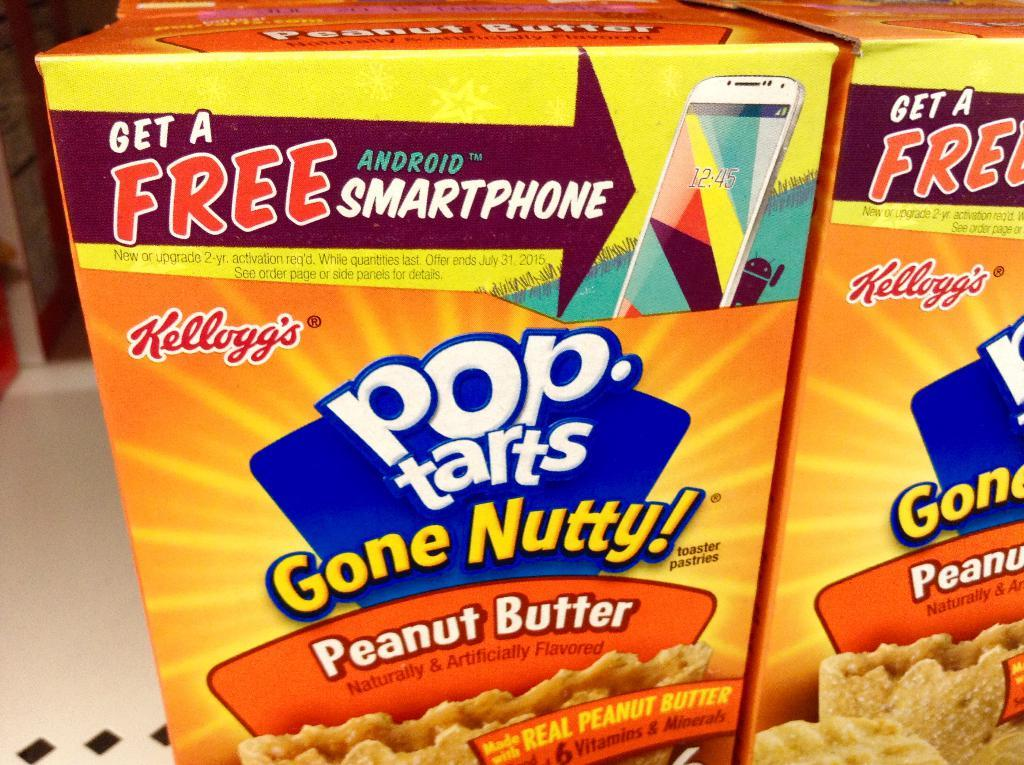<image>
Write a terse but informative summary of the picture. a box of pop tarsk gone nutty! peanut butter variety 